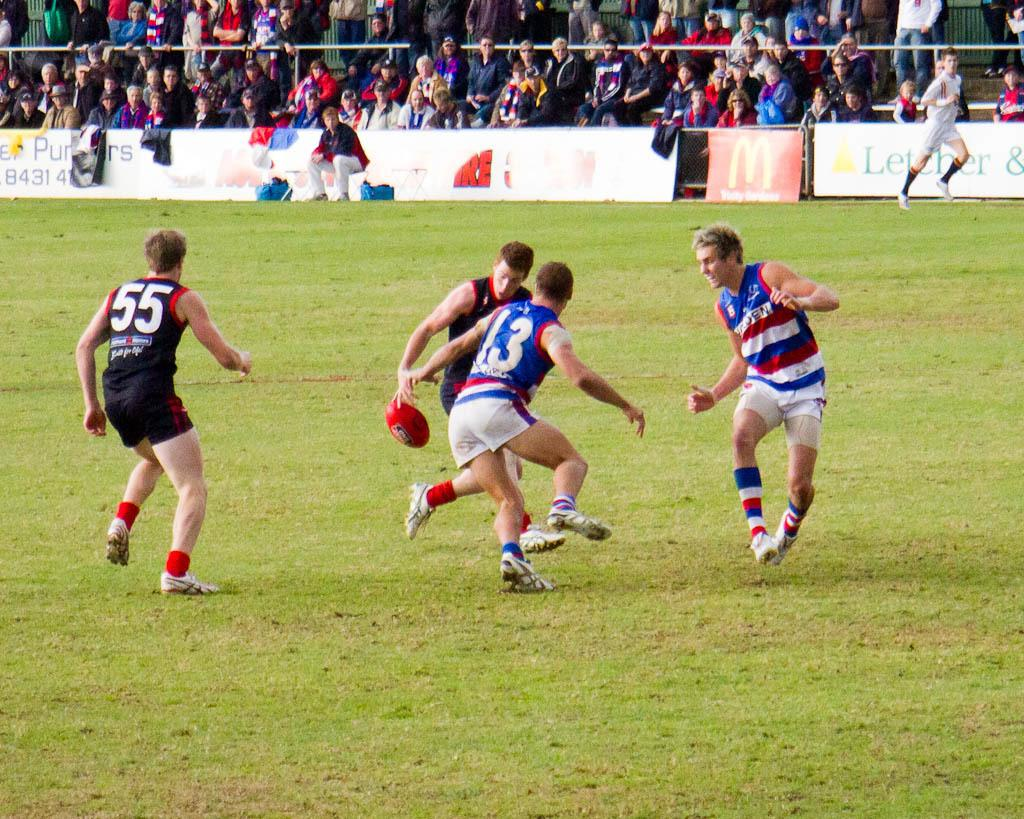<image>
Provide a brief description of the given image. A rugby match is being played in a field where Mcdonald's advertisement can be seen. 